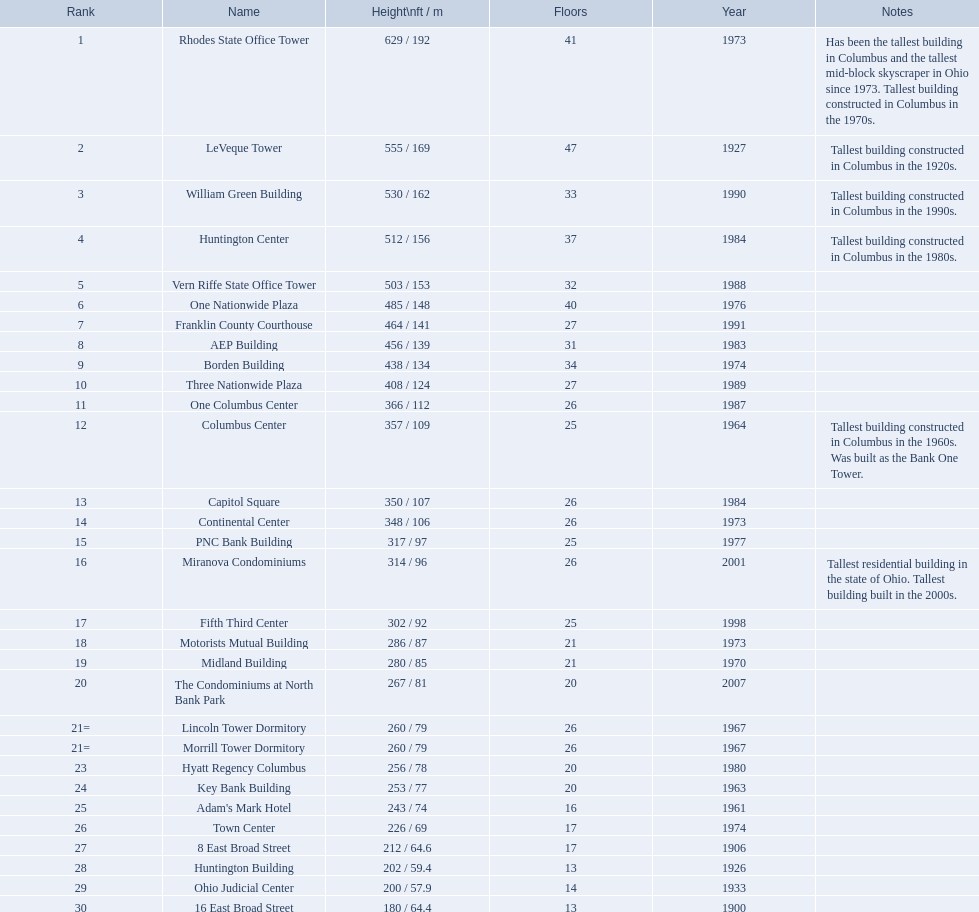What are the vertical extents of all the constructions? 629 / 192, 555 / 169, 530 / 162, 512 / 156, 503 / 153, 485 / 148, 464 / 141, 456 / 139, 438 / 134, 408 / 124, 366 / 112, 357 / 109, 350 / 107, 348 / 106, 317 / 97, 314 / 96, 302 / 92, 286 / 87, 280 / 85, 267 / 81, 260 / 79, 260 / 79, 256 / 78, 253 / 77, 243 / 74, 226 / 69, 212 / 64.6, 202 / 59.4, 200 / 57.9, 180 / 64.4. What are the vertical extents of the aep and columbus center constructions? 456 / 139, 357 / 109. Which extent is larger? 456 / 139. Which construction is this concerning? AEP Building. 